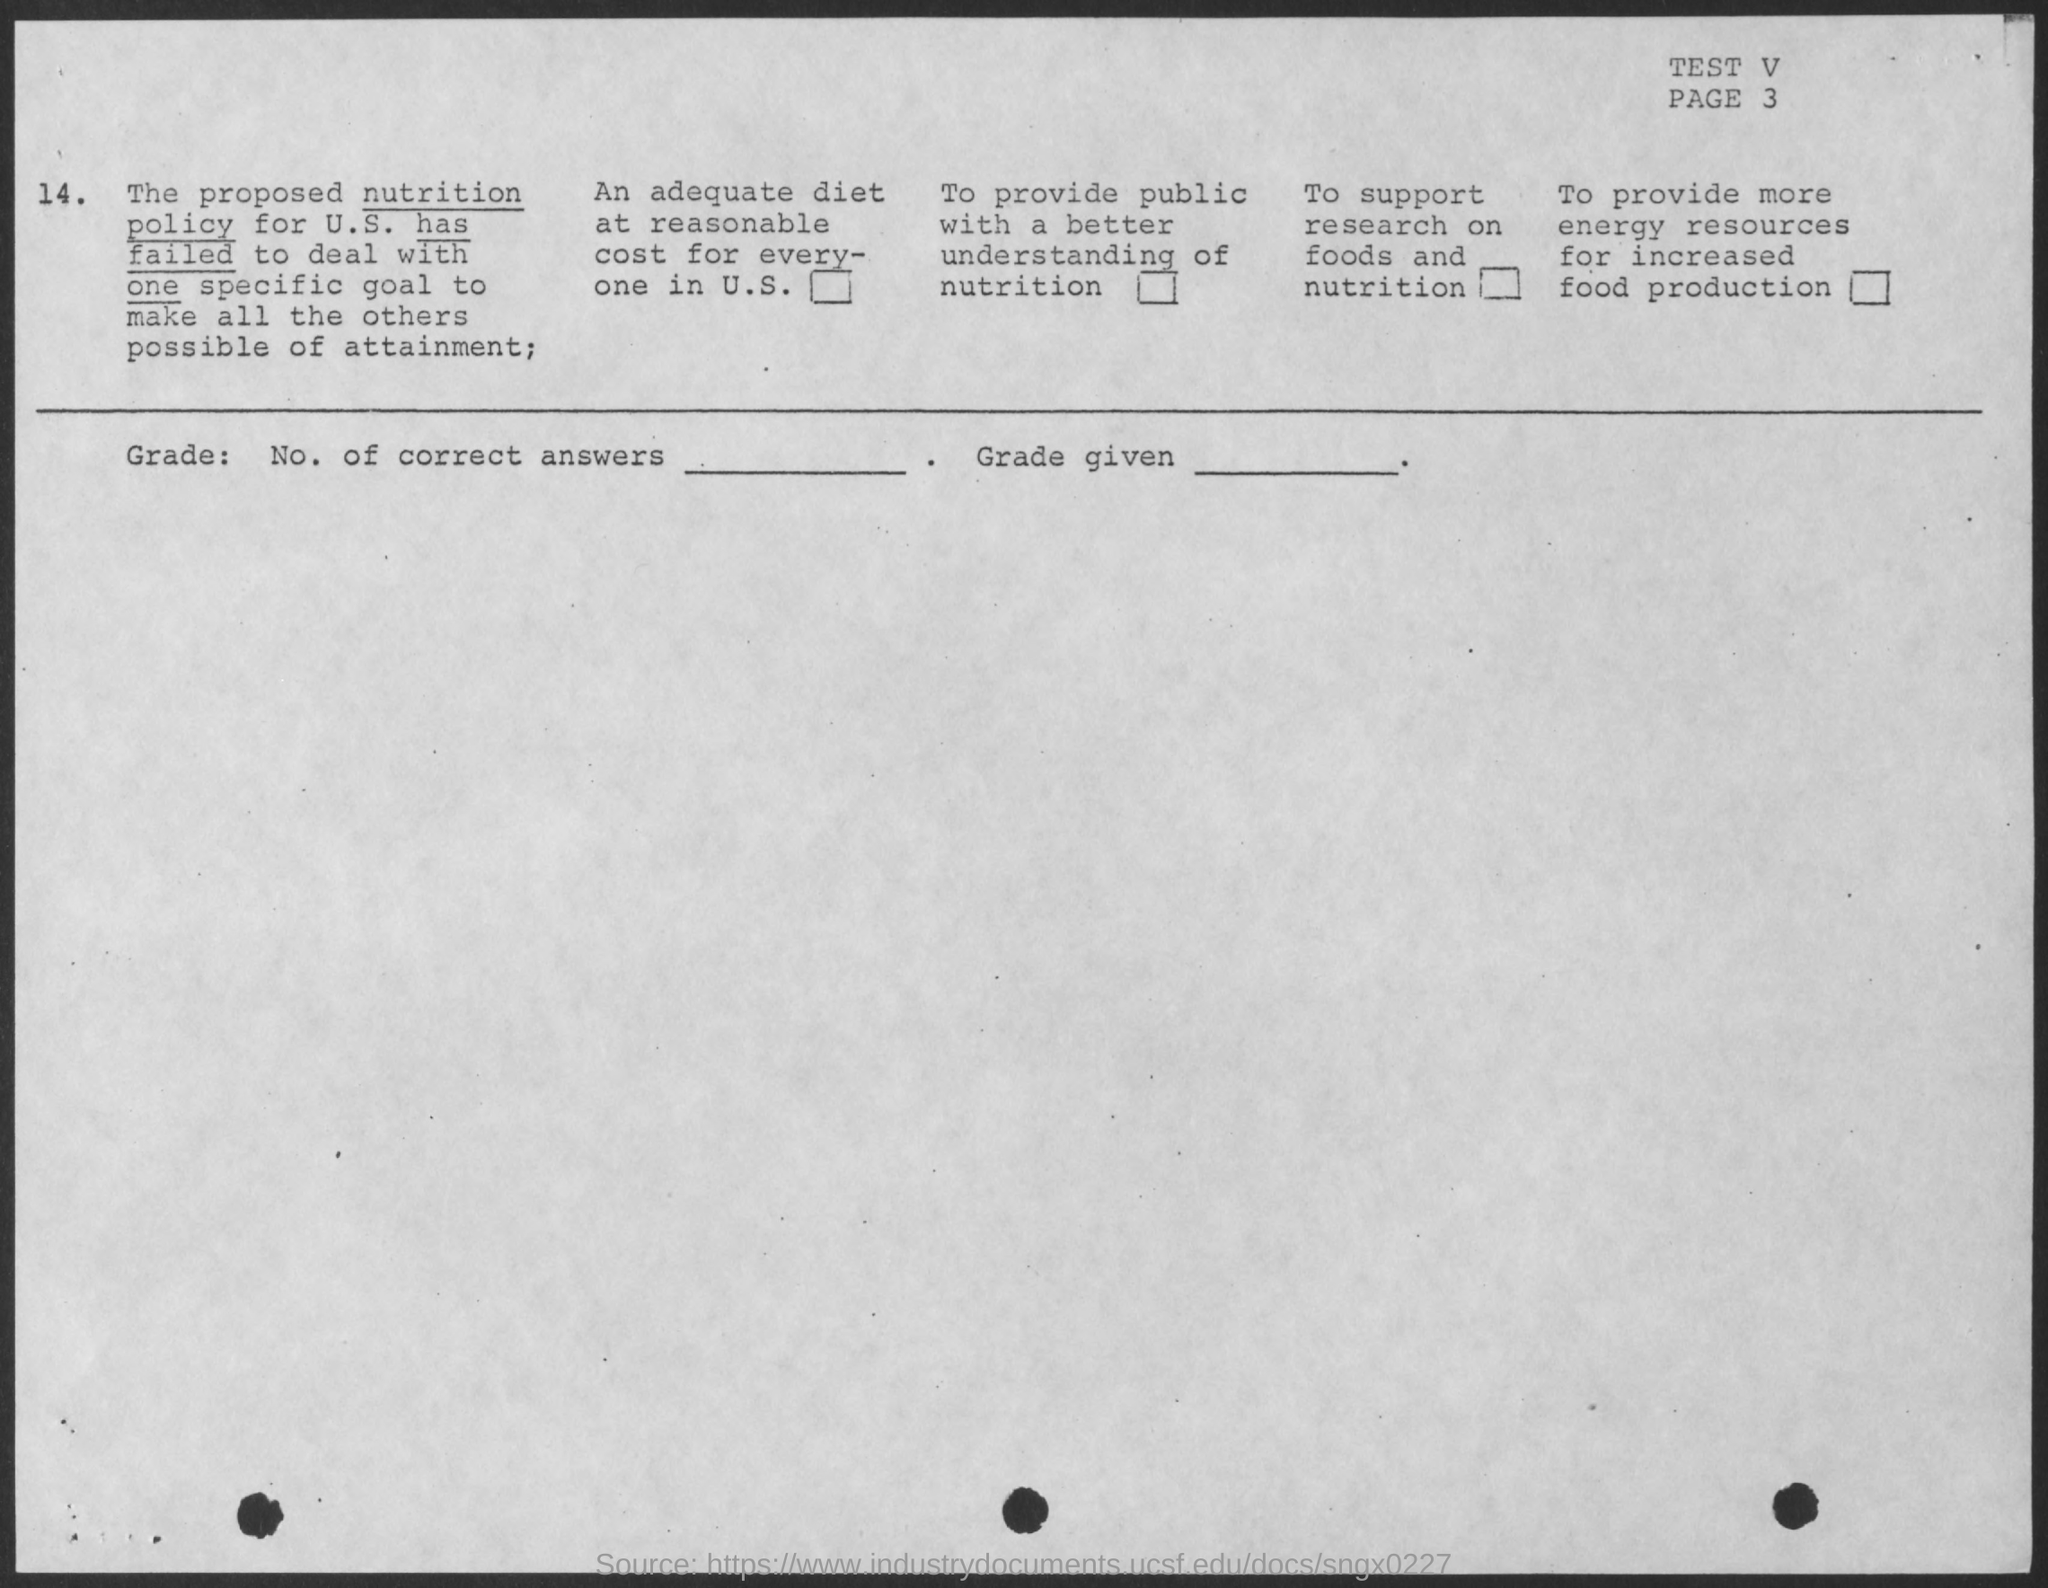Specify some key components in this picture. The test number is V...," declares the speaker. The U.S. has a nutrition policy. The page number is 3. 